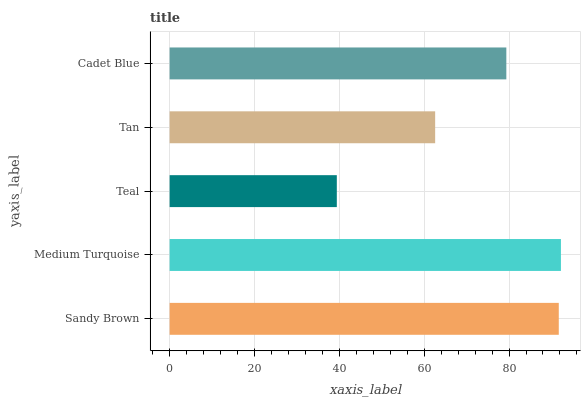Is Teal the minimum?
Answer yes or no. Yes. Is Medium Turquoise the maximum?
Answer yes or no. Yes. Is Medium Turquoise the minimum?
Answer yes or no. No. Is Teal the maximum?
Answer yes or no. No. Is Medium Turquoise greater than Teal?
Answer yes or no. Yes. Is Teal less than Medium Turquoise?
Answer yes or no. Yes. Is Teal greater than Medium Turquoise?
Answer yes or no. No. Is Medium Turquoise less than Teal?
Answer yes or no. No. Is Cadet Blue the high median?
Answer yes or no. Yes. Is Cadet Blue the low median?
Answer yes or no. Yes. Is Sandy Brown the high median?
Answer yes or no. No. Is Tan the low median?
Answer yes or no. No. 